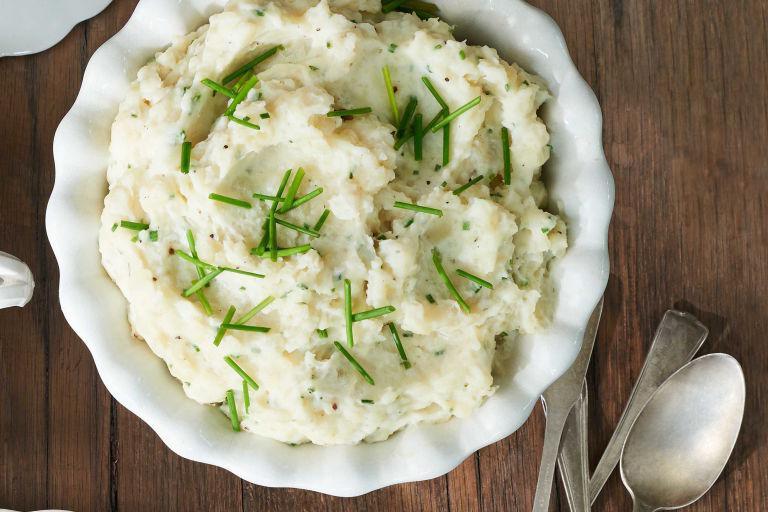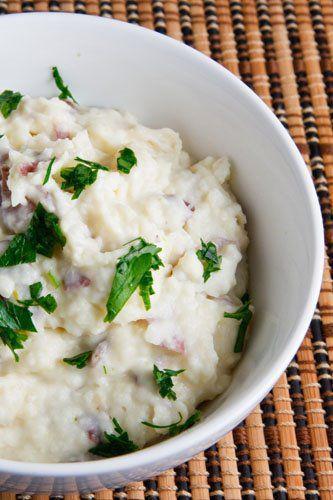The first image is the image on the left, the second image is the image on the right. For the images displayed, is the sentence "One image shows potatoes garnished with green bits and served in a shiny olive green bowl." factually correct? Answer yes or no. No. The first image is the image on the left, the second image is the image on the right. Analyze the images presented: Is the assertion "In one of the images, the mashed potatoes are in a green bowl." valid? Answer yes or no. No. 